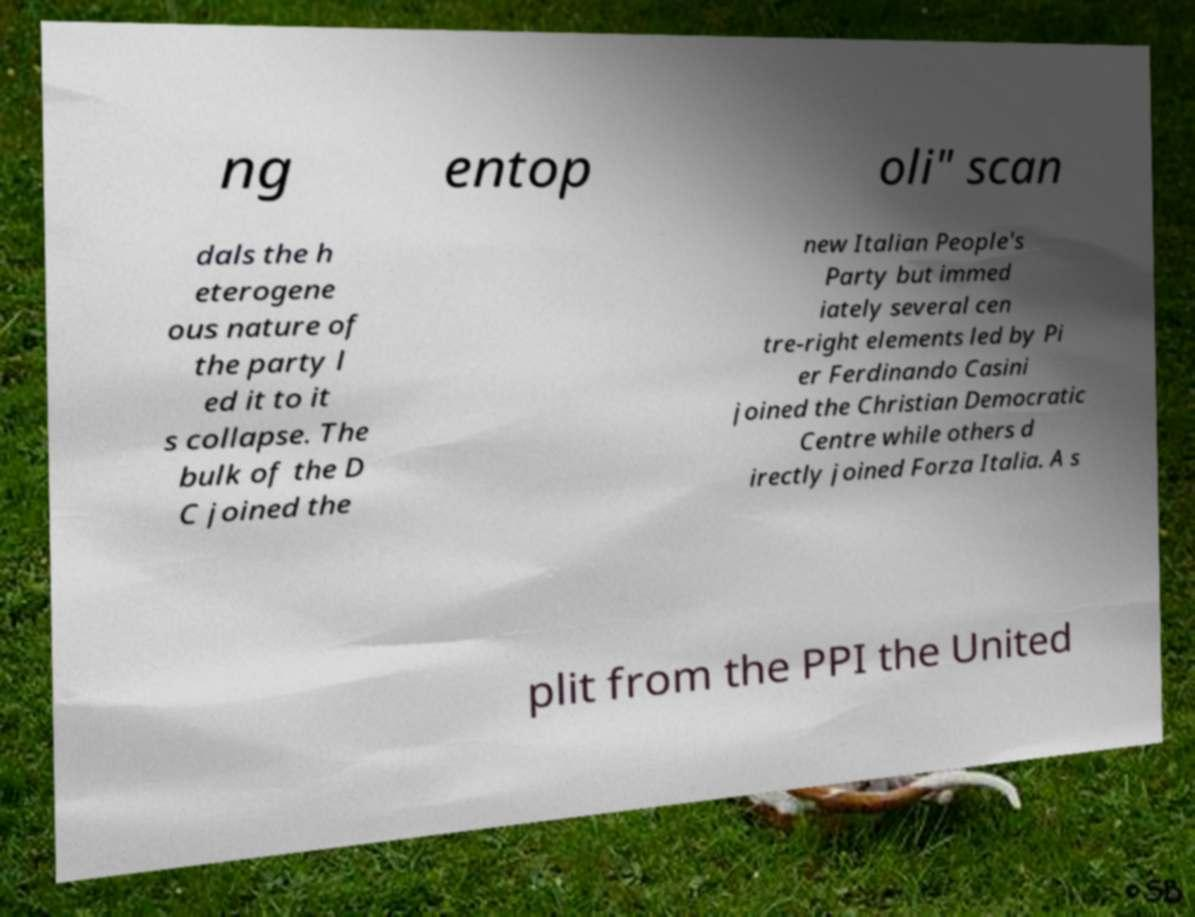There's text embedded in this image that I need extracted. Can you transcribe it verbatim? ng entop oli" scan dals the h eterogene ous nature of the party l ed it to it s collapse. The bulk of the D C joined the new Italian People's Party but immed iately several cen tre-right elements led by Pi er Ferdinando Casini joined the Christian Democratic Centre while others d irectly joined Forza Italia. A s plit from the PPI the United 